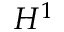<formula> <loc_0><loc_0><loc_500><loc_500>H ^ { 1 }</formula> 